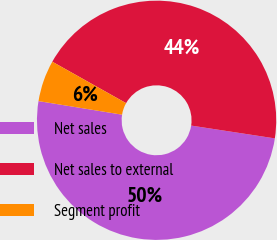Convert chart to OTSL. <chart><loc_0><loc_0><loc_500><loc_500><pie_chart><fcel>Net sales<fcel>Net sales to external<fcel>Segment profit<nl><fcel>50.14%<fcel>44.27%<fcel>5.58%<nl></chart> 